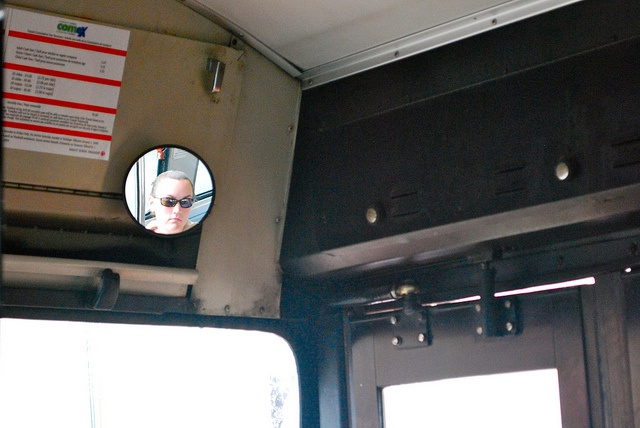Describe the objects in this image and their specific colors. I can see people in black, white, lightpink, gray, and darkgray tones in this image. 